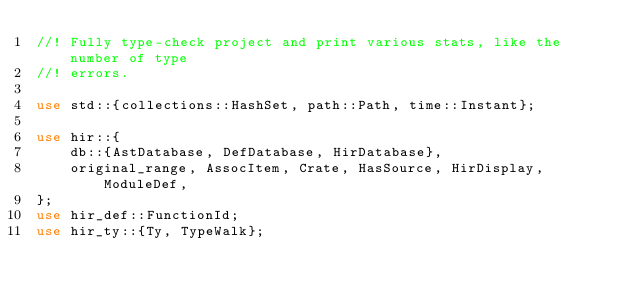<code> <loc_0><loc_0><loc_500><loc_500><_Rust_>//! Fully type-check project and print various stats, like the number of type
//! errors.

use std::{collections::HashSet, path::Path, time::Instant};

use hir::{
    db::{AstDatabase, DefDatabase, HirDatabase},
    original_range, AssocItem, Crate, HasSource, HirDisplay, ModuleDef,
};
use hir_def::FunctionId;
use hir_ty::{Ty, TypeWalk};</code> 